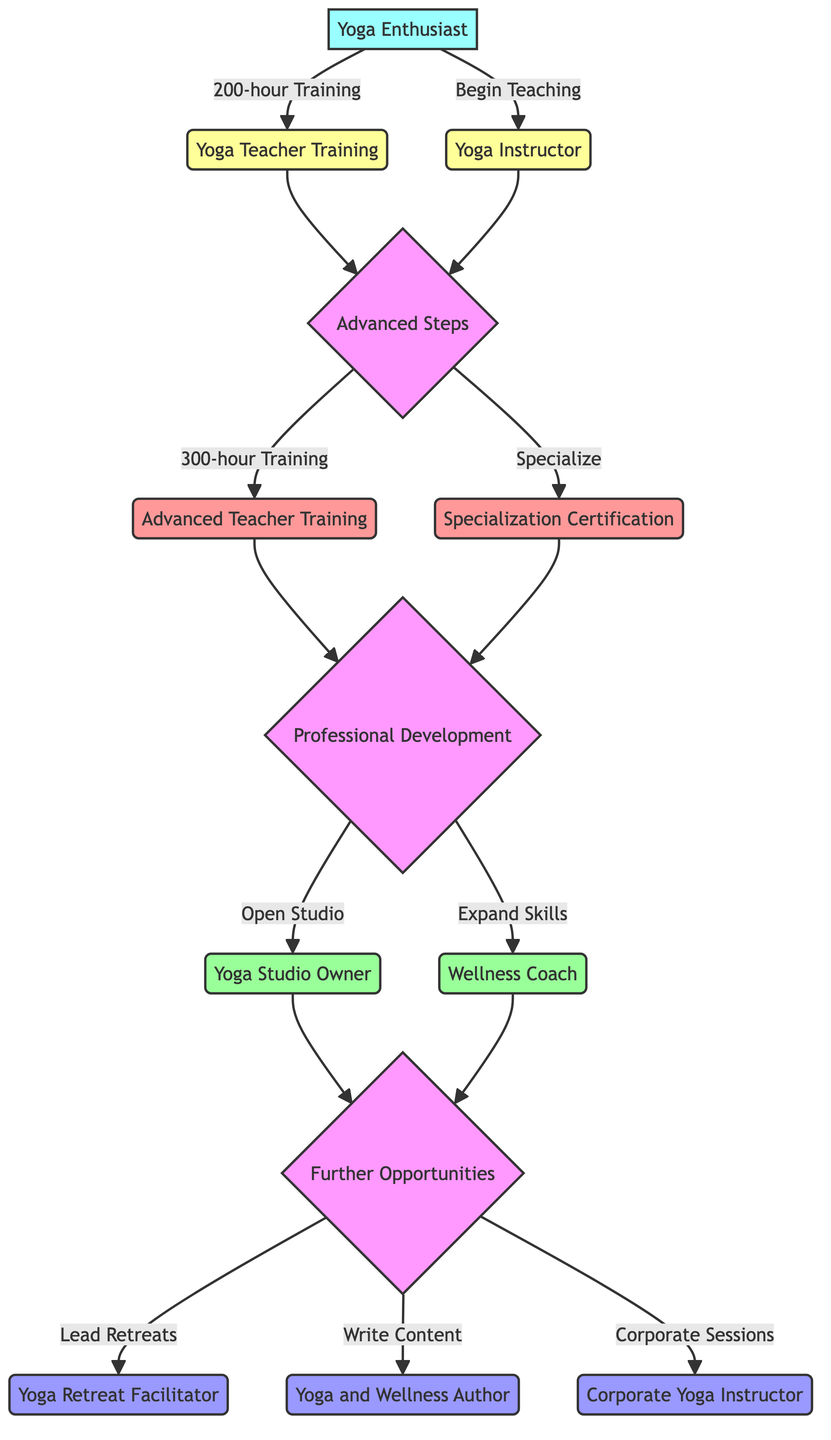What is the starting point in the career progression pathway? The starting point in the diagram is labeled "Yoga Enthusiast," which indicates the beginning of the pathway for individuals.
Answer: Yoga Enthusiast How many advanced steps are listed in the diagram? The diagram outlines two advanced steps: "Advanced Teacher Training" and "Specialization Certification." Therefore, we count these two nodes to determine the total number of advanced steps.
Answer: 2 What is one role that comes after the Yoga Instructor? After reaching the "Yoga Instructor" node, the next step leads to the “Advanced Steps” node, where an individual can choose to pursue either "Advanced Teacher Training" or "Specialization Certification." Therefore, one role following "Yoga Instructor" can be "Advanced Teacher Training."
Answer: Advanced Teacher Training What can a Wellness Coach do after their professional development? A "Wellness Coach" can explore further opportunities such as becoming a "Yoga Retreat Facilitator," "Yoga and Wellness Author," or "Corporate Yoga Instructor." To identify what a Wellness Coach can specifically do, we look at the "Further Opportunities" node connected to it.
Answer: Yoga Retreat Facilitator What are the two ways to progress after completing Yoga Instructor training? After completing Yoga Instructor training at the "Yoga Instructor" node, individuals can progress to either the "Advanced Steps" or pursue opportunities related to "Professional Development." Thus, we interpret the arrows leading from the "Yoga Instructor" node to understand the progression pathways.
Answer: Advanced Steps, Professional Development What is the final node in the career progression pathway? The final nodes in the pathway are "Yoga Retreat Facilitator," "Yoga and Wellness Author," and "Corporate Yoga Instructor," indicating various opportunities one can pursue after professional development. Each option stems from the "Further Opportunities" node, displaying the options available at the conclusion of the pathway.
Answer: Yoga Retreat Facilitator, Yoga and Wellness Author, Corporate Yoga Instructor 